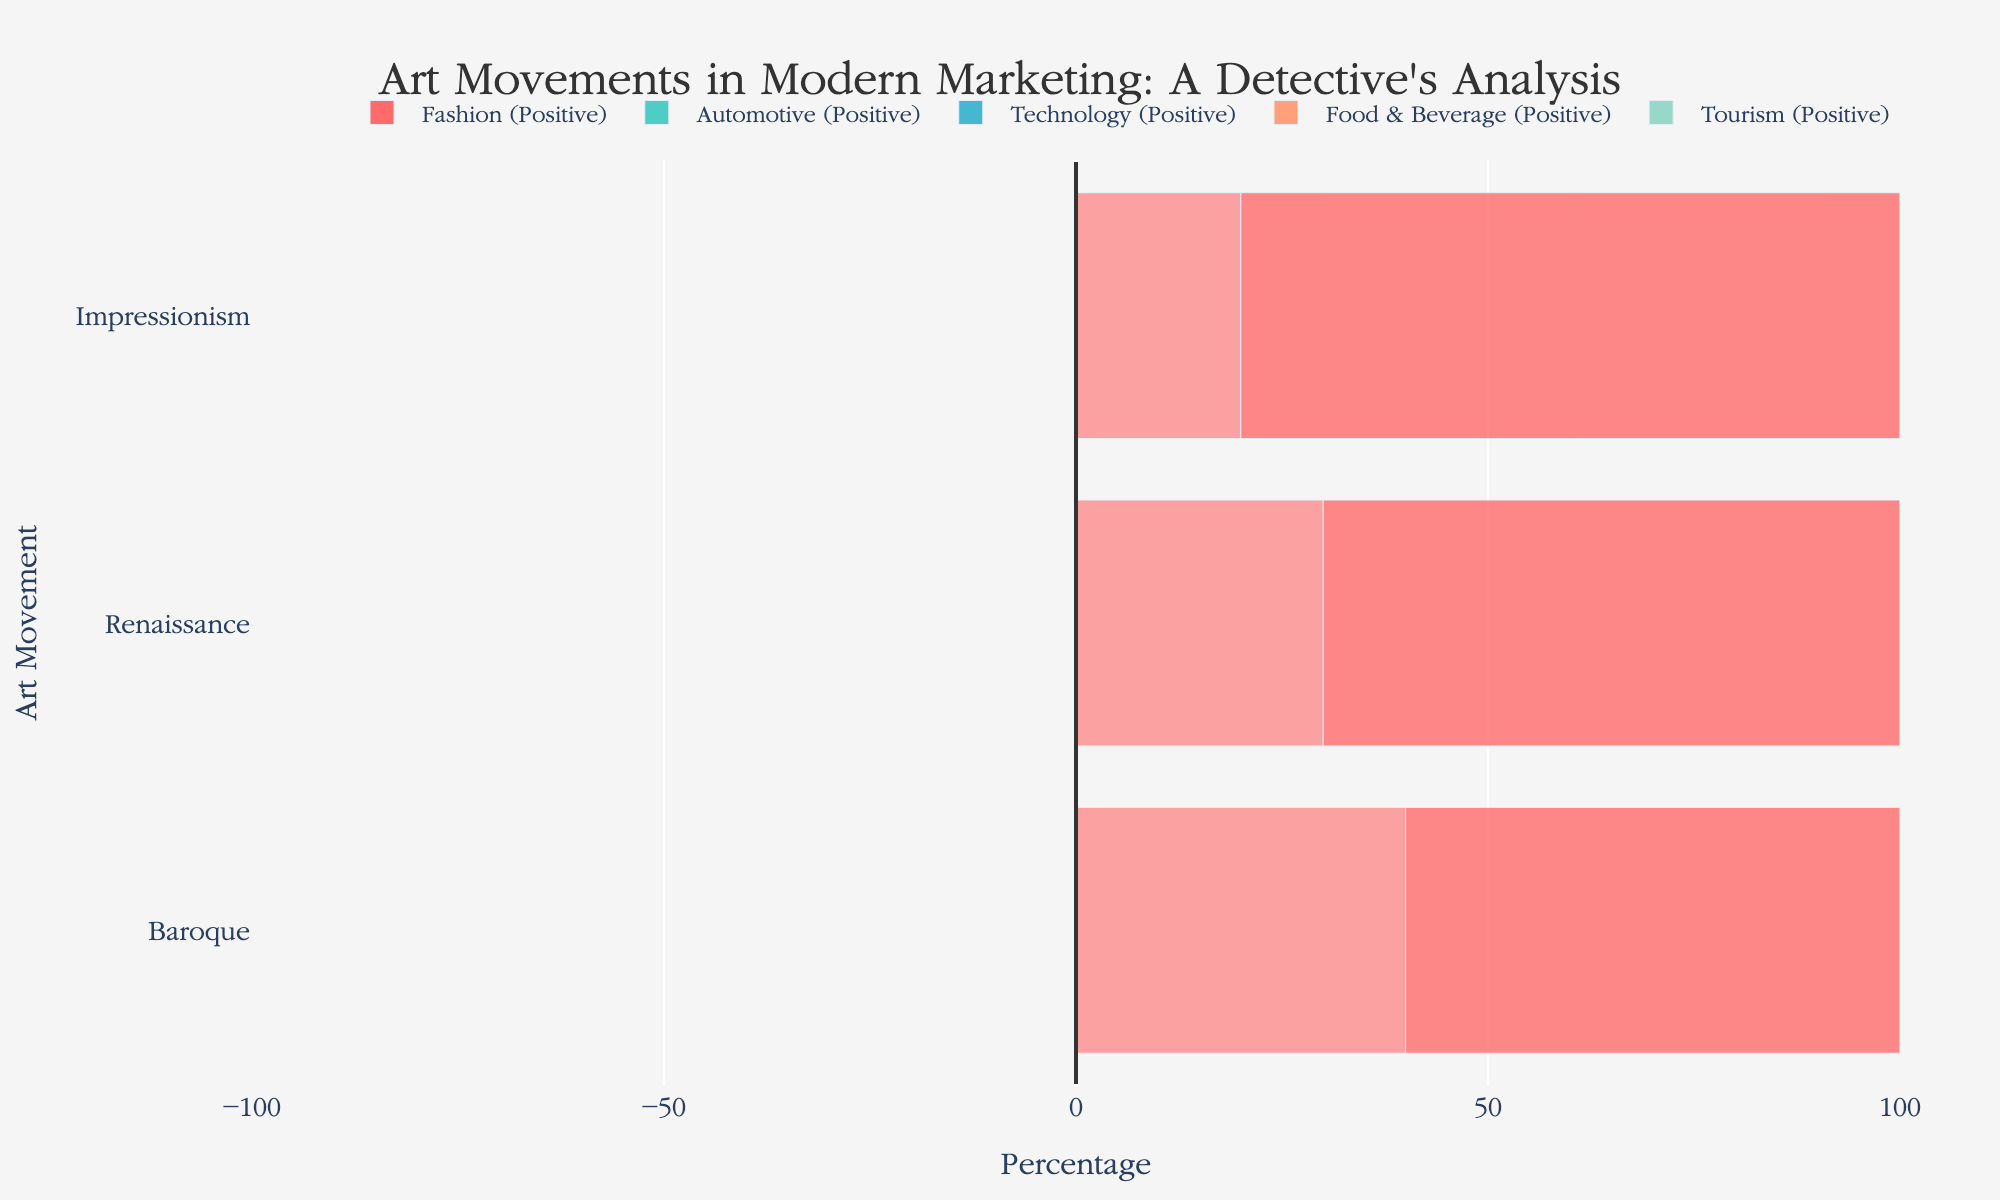Which industry uses the Renaissance art movement the most positively? Compare the positive usage of the Renaissance art movement across all industries. The Tourism industry has the highest positive usage at 75%.
Answer: Tourism Which art movement has the highest net usage in the Fashion industry? Evaluate the net usage of all art movements within the Fashion industry. Impressionism has the highest net usage at 60%.
Answer: Impressionism What is the combined net usage of the Renaissance art movement in Fashion and Automotive industries? Calculate the net usage of the Renaissance art movement in Fashion (40) and Automotive (-20), then sum them up: 40 + (-20) = 20.
Answer: 20 Which industry has the least negative usage of the Baroque art movement? Examine the negative usage of the Baroque art movement across all industries. The Automotive industry has the lowest negative usage at 25%.
Answer: Automotive For the Food & Beverage industry, what is the average positive usage across all art movements? Calculate the average positive usage by summing the positive usage percentages (45 + 50 + 85) and dividing by the number of art movements: (45 + 50 + 85) / 3 = 60.
Answer: 60 In the Technology industry, does the net usage of Impressionism exceed the combined net usage of Renaissance and Baroque? Calculate the net usage for each art movement in Technology: Renaissance (10), Baroque (30), Impressionism (40). Combine the net usage of Renaissance and Baroque: 10 + 30 = 40; Compare with Impressionism (40). They are equal.
Answer: No Which art movement shows the highest total positive percentage across all industries? Sum the positive percentages for each art movement across all industries and compare. Impressionism has the highest total positive percentage.
Answer: Impressionism What is the difference in net usage of Impressionism between the Fashion and Tourism industries? Calculate the net usage of Impressionism in Fashion (60) and Tourism (10) and find the difference: 60 - 10 = 50.
Answer: 50 Between the Food & Beverage and Tourism industries, which one has a higher negative usage of the Renaissance art movement? Compare the negative usage of the Renaissance art movement in Food & Beverage (55) and Tourism (25). Food & Beverage has a higher negative usage.
Answer: Food & Beverage 